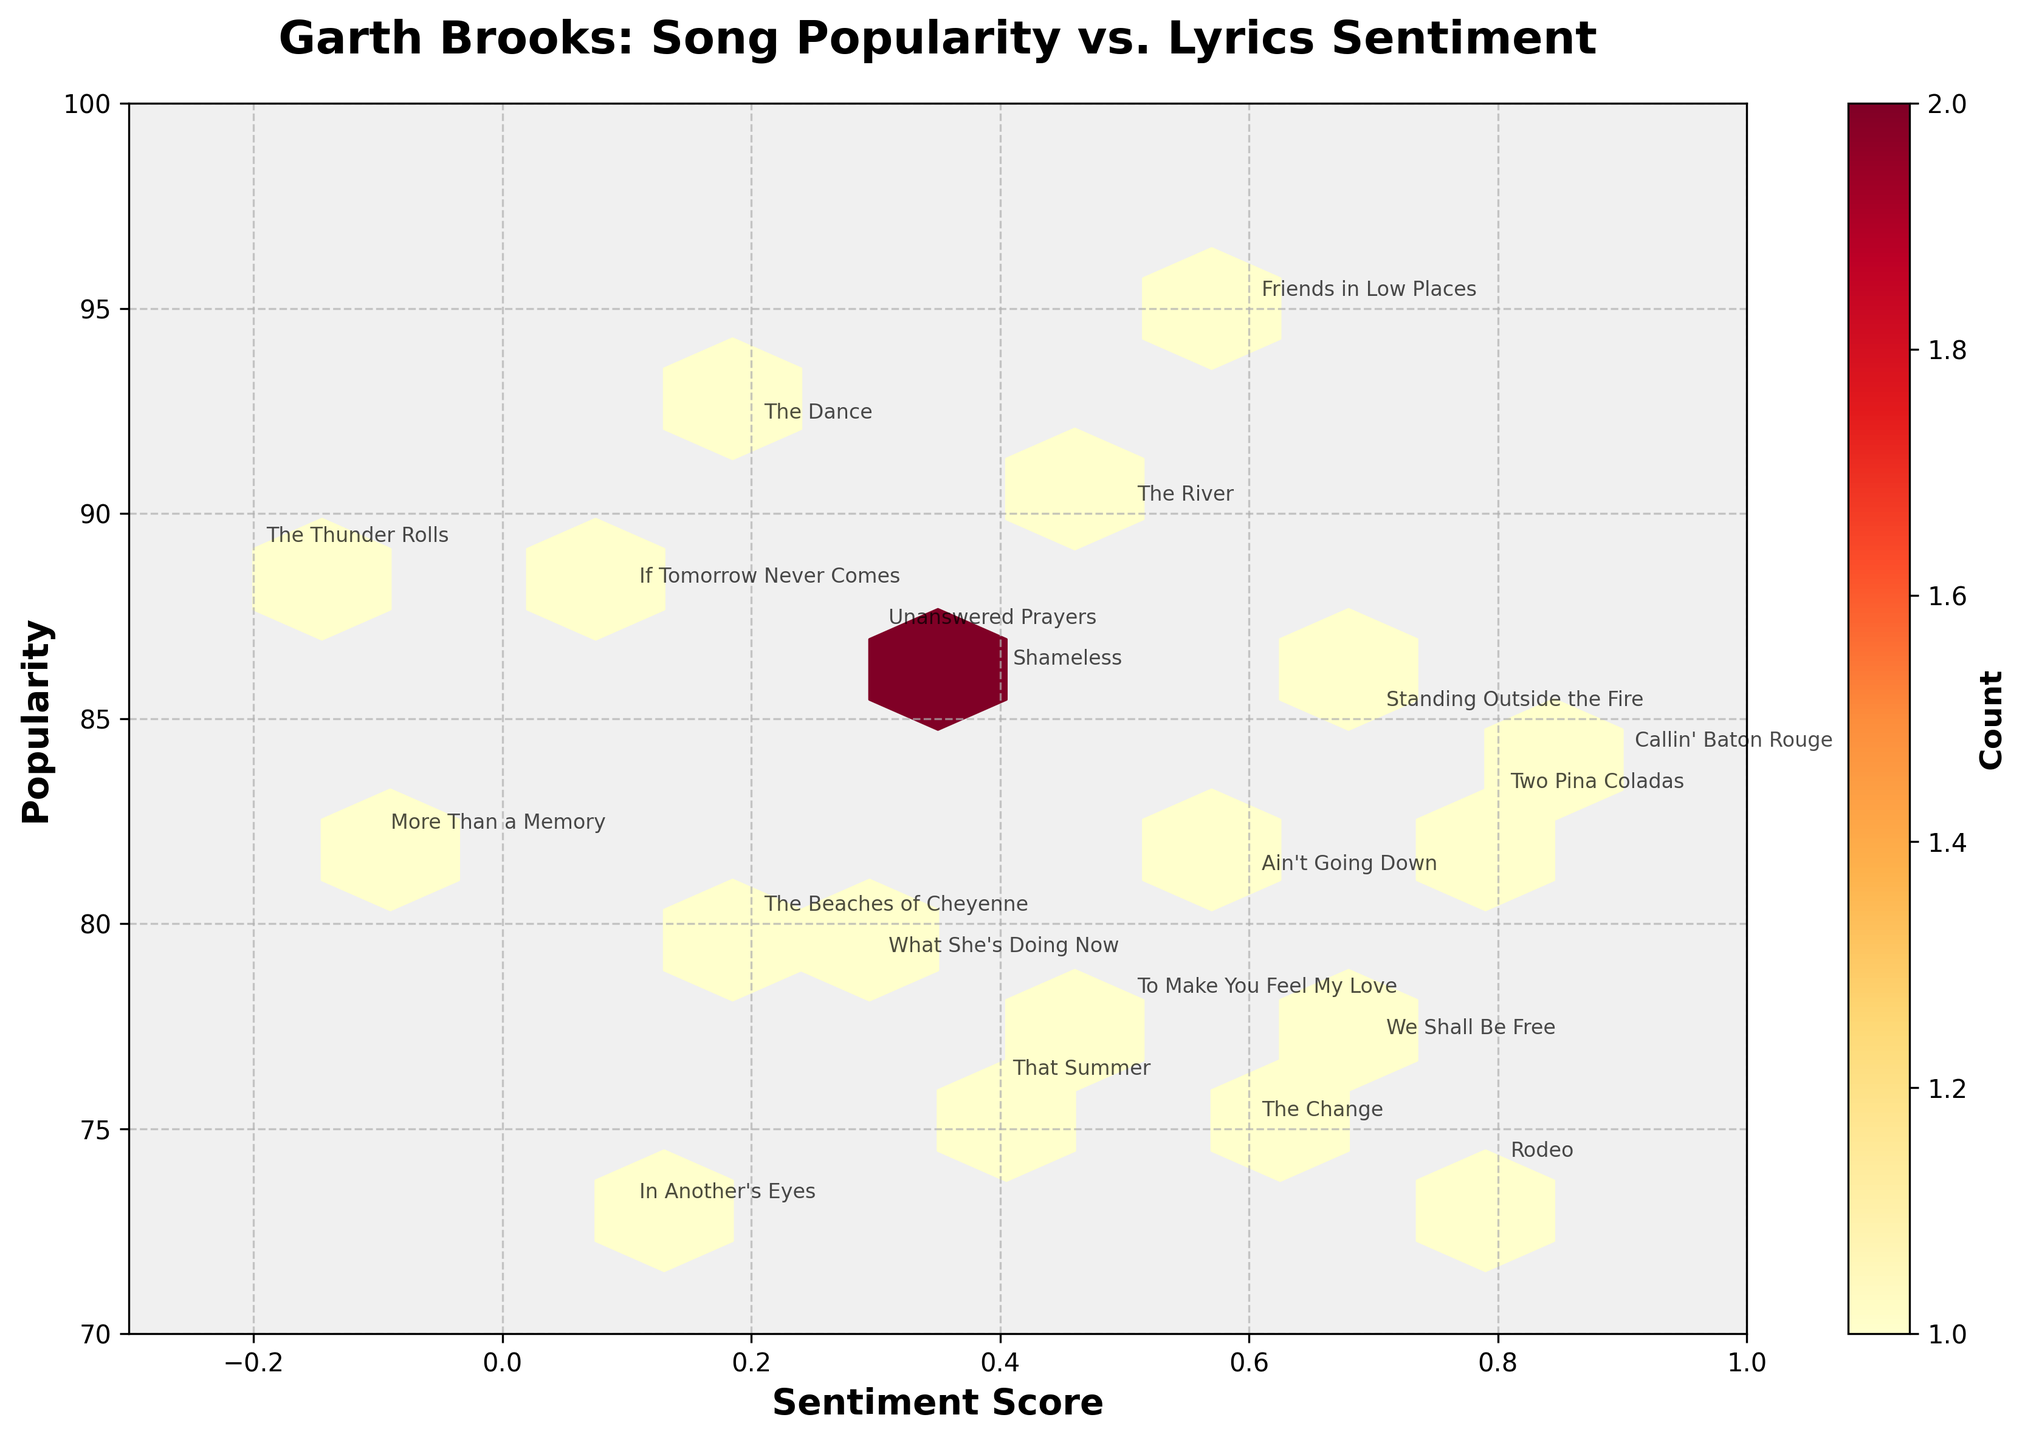What is the title of the hexbin plot? The title of a plot is usually displayed at the top center of the figure. Here, the title reads "Garth Brooks: Song Popularity vs. Lyrics Sentiment".
Answer: Garth Brooks: Song Popularity vs. Lyrics Sentiment Which axes represent sentiment score and popularity in the hexbin plot? The x-axis represents the sentiment score and the y-axis represents the popularity score. This can be identified by looking at the labels on the respective axes.
Answer: Sentiment score on x-axis, Popularity on y-axis What color range is used in the hexbin plot to represent counts? By observing the color bar on the right side of the plot, we see that it ranges from yellow to dark red, indicating increasing counts.
Answer: Yellow to dark red How many songs have a sentiment score between 0.5 and 0.7? To find this, locate the hexbin cells between 0.5 and 0.7 on the x-axis and count the number of songs annotated within these cells.
Answer: 6 songs Which song has the highest popularity and what is its sentiment score? By looking at the topmost point on the y-axis (popularity 95), we can see the annotation for "Friends in Low Places" with a sentiment score of 0.6.
Answer: Friends in Low Places, 0.6 What is the average sentiment score of songs with popularity greater than 85? To determine this, first identify all the songs with popularity > 85. The songs are "Friends in Low Places" (0.6), "The Dance" (0.2), "If Tomorrow Never Comes" (0.1), "Unanswered Prayers" (0.3), and "The Thunder Rolls" (-0.2). Calculating the average: (0.6 + 0.2 + 0.1 + 0.3 - 0.2) / 5.
Answer: 0.2 Which song annotations are placed within the lowest popularity range (below 75)? Observe the y-axis and identify annotations below 75. These are "We Shall Be Free," "That Summer," "The Change," "Rodeo," and "In Another's Eyes."
Answer: We Shall Be Free, That Summer, The Change, Rodeo, In Another's Eyes How does the song "The Thunder Rolls" compare in sentiment score and popularity with "Callin' Baton Rouge"? By identifying and comparing the two songs' positions: "The Thunder Rolls" has a sentiment score of -0.2 and popularity of 89, while "Callin' Baton Rouge" has a sentiment score of 0.9 and popularity of 84.
Answer: The Thunder Rolls has lower sentiment and higher popularity What is the sentiment score range for the data points shown on the hexbin plot? By looking at the x-axis limits set on the plot, the sentiment score ranges from -0.3 to 1.0.
Answer: -0.3 to 1.0 Which sentiment score range has the highest density of songs, and what does the color indicate about this density? The color intensity on the plot shows the highest density appears between 0.5 and 0.7 sentiment score. The dark red color in this range indicates the highest count of songs.
Answer: 0.5 to 0.7, high density 